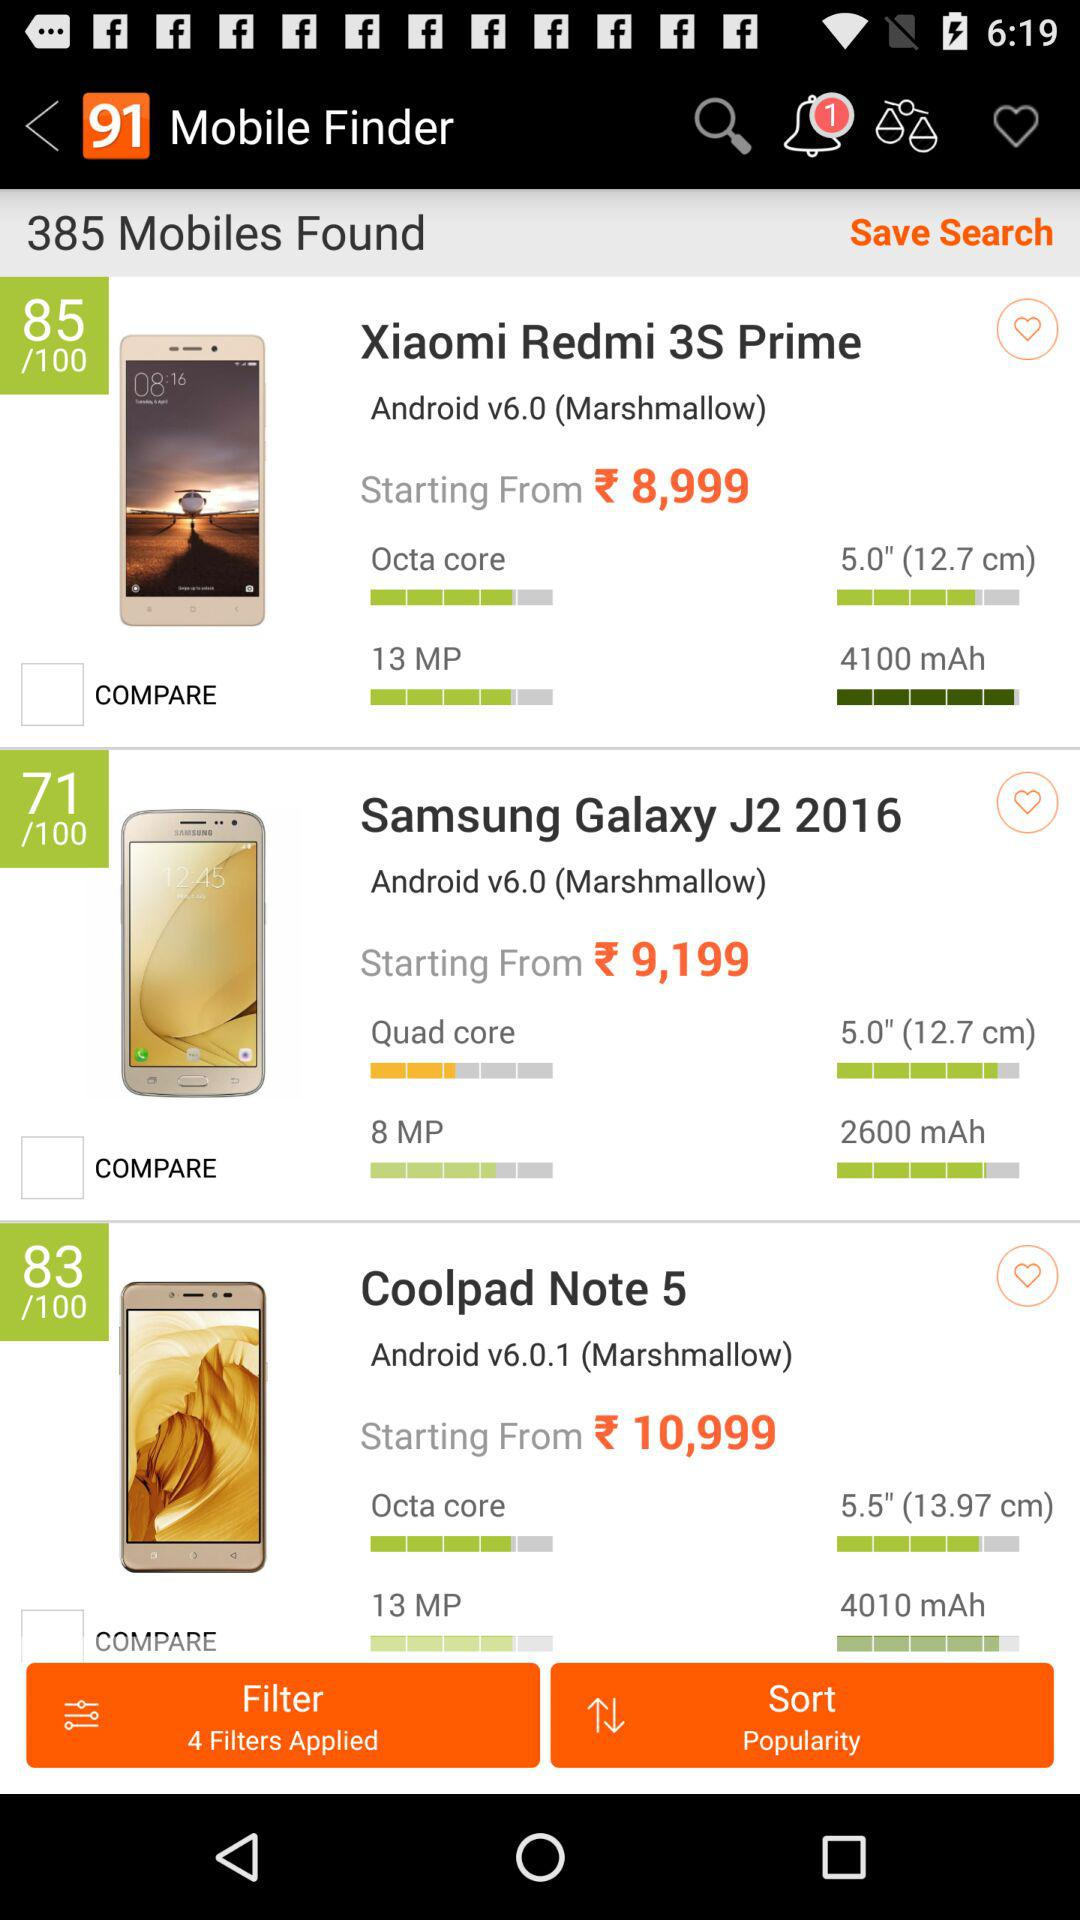How much more does the Coolpad Note 5 cost than the Samsung Galaxy J2 2016?
Answer the question using a single word or phrase. 1800 